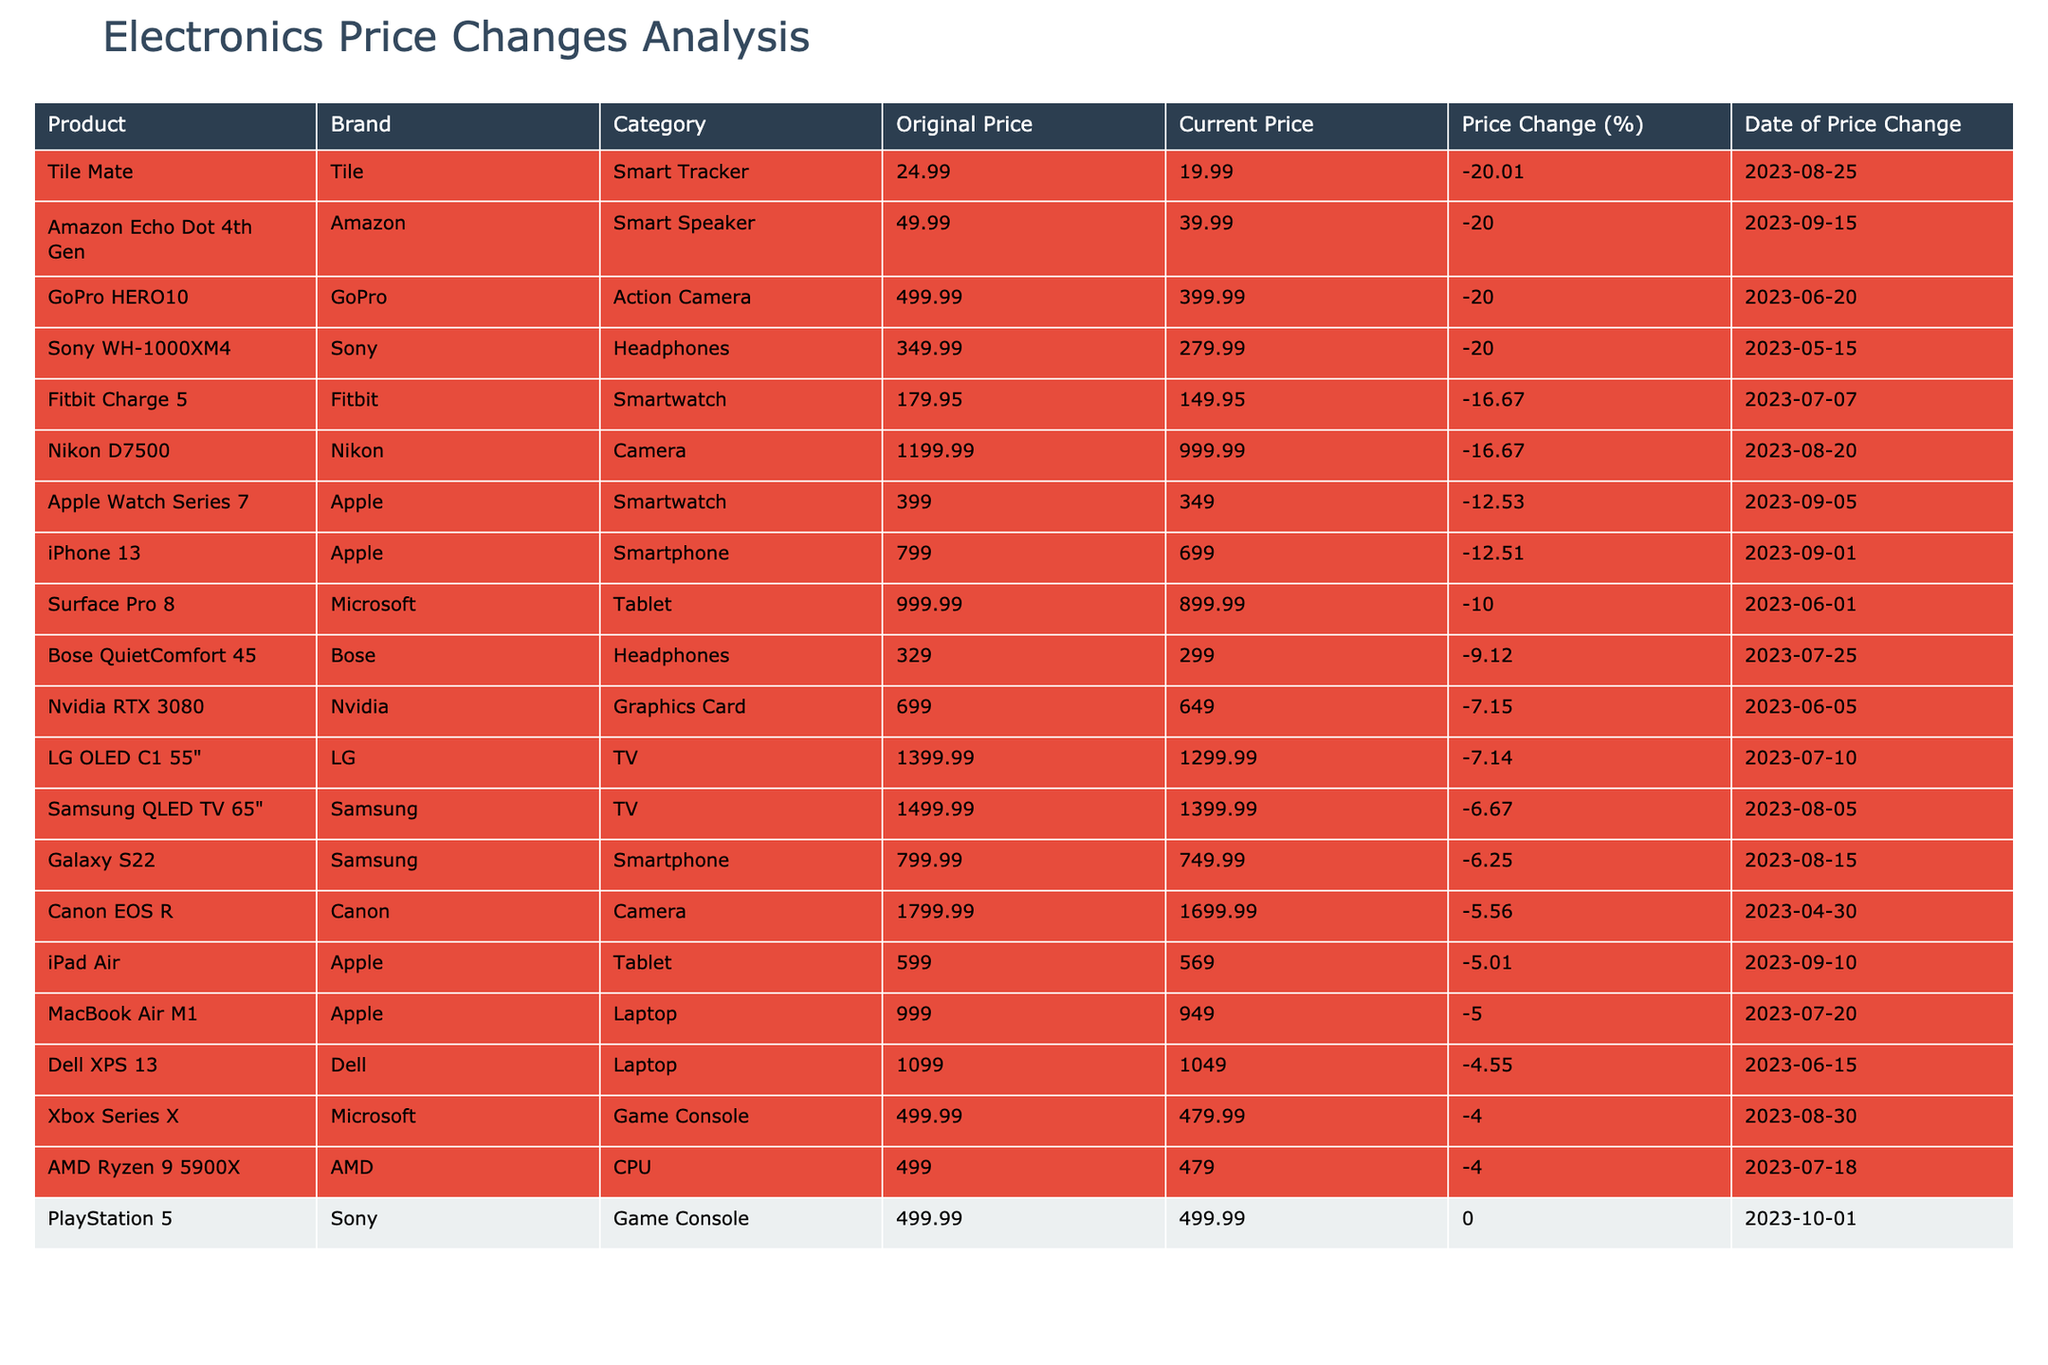What is the current price of the iPhone 13? The table indicates that the current price of the iPhone 13, as listed under the "Current Price" column, is $699.00.
Answer: 699.00 Which product has the highest percentage of price reduction? By reviewing the "Price Change (%)" column, the highest price reduction is -20.00% for the Sony WH-1000XM4 and the Tile Mate.
Answer: Sony WH-1000XM4 / Tile Mate What is the total price reduction for all products in the table? To find the total price reduction, add up the original prices and subtract the current prices: Total Original Price = 799 + 799.99 + ... + 499.00 = 10901.91; Total Current Price = 699 + 749.99 + ... + 479.00 = 9964.86; Price Reduction = 10901.91 - 9964.86 = 937.05.
Answer: 937.05 Is the current price of the Dell XPS 13 greater than its original price? According to the table, the original price is $1,099.00 and the current price is $1,049.00, which shows that the current price is less than the original price.
Answer: No What percentage change in price did the Samsung QLED TV experience? The table states that the original price of the Samsung QLED TV is $1,499.99 and the current price is $1,399.99. To calculate the percentage change: Price Change = (Original Price - Current Price) / Original Price * 100 = (1499.99 - 1399.99) / 1499.99 * 100 = -6.67%.
Answer: -6.67% Which brands had products that experienced a price reduction of more than 10%? By examining the table, the products that experienced over a 10% reduction are from brands Apple (iPhone 13 and Apple Watch Series 7), Bose, Sony, GoPro, and Tile.
Answer: Apple, Bose, Sony, GoPro, Tile What is the average current price of the products in the Tablet category? To determine the average current price for the Tablets (iPad Air and Surface Pro 8): Current Prices = 569.00 + 899.99 = 1468.99; Average = 1468.99 / 2 = 734.495.
Answer: 734.50 Have the prices of any game consoles increased over the past year? The table indicates that both the PlayStation 5 and the Xbox Series X have experienced price changes; however, the PlayStation 5 shows no price change (0.00%), indicating that its price has not increased or decreased, while the Xbox Series X has decreased in price.
Answer: No What is the price difference between the Nikon D7500 and the Canon EOS R after the recent price changes? The current price of the Nikon D7500 is $999.99 and the Canon EOS R is $1,699.99. The price difference is calculated as $1,699.99 - $999.99 = $700.00.
Answer: 700.00 